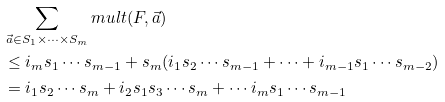Convert formula to latex. <formula><loc_0><loc_0><loc_500><loc_500>& \sum _ { \vec { a } \in S _ { 1 } \times \cdots \times S _ { m } } { m u l t } ( F , \vec { a } ) \\ & \leq i _ { m } s _ { 1 } \cdots s _ { m - 1 } + s _ { m } ( i _ { 1 } s _ { 2 } \cdots s _ { m - 1 } + \cdots + i _ { m - 1 } s _ { 1 } \cdots s _ { m - 2 } ) \\ & = i _ { 1 } s _ { 2 } \cdots s _ { m } + i _ { 2 } s _ { 1 } s _ { 3 } \cdots s _ { m } + \cdots i _ { m } s _ { 1 } \cdots s _ { m - 1 }</formula> 